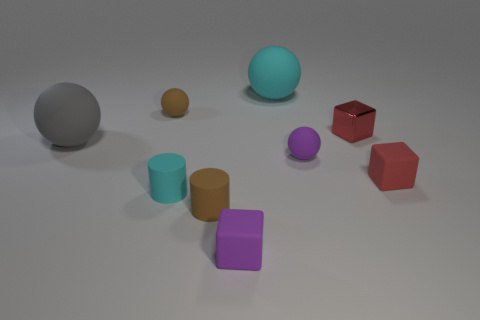Subtract 1 spheres. How many spheres are left? 3 Add 1 small things. How many objects exist? 10 Subtract all balls. How many objects are left? 5 Subtract all small blocks. Subtract all brown matte cylinders. How many objects are left? 5 Add 5 gray objects. How many gray objects are left? 6 Add 7 metallic cubes. How many metallic cubes exist? 8 Subtract 1 gray balls. How many objects are left? 8 